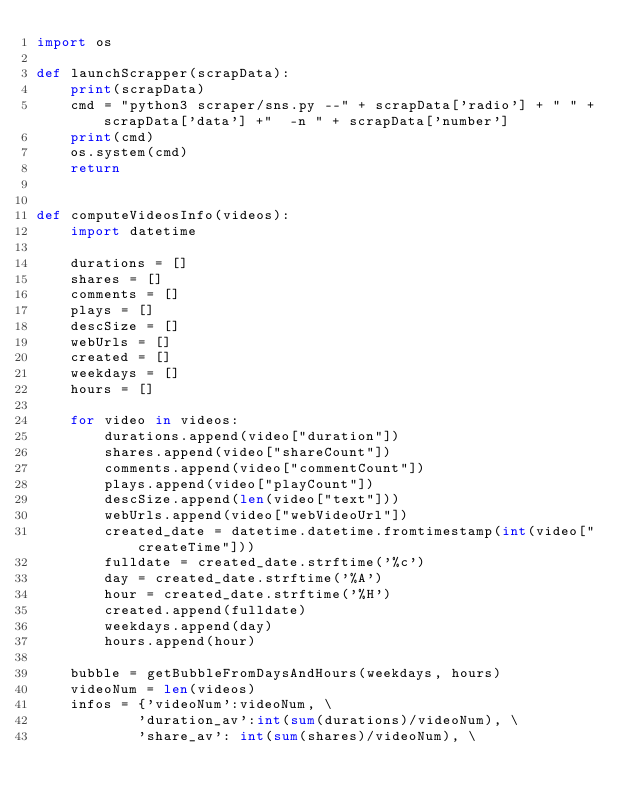Convert code to text. <code><loc_0><loc_0><loc_500><loc_500><_Python_>import os

def launchScrapper(scrapData):
    print(scrapData)
    cmd = "python3 scraper/sns.py --" + scrapData['radio'] + " " + scrapData['data'] +"  -n " + scrapData['number']
    print(cmd)
    os.system(cmd)
    return 


def computeVideosInfo(videos):
    import datetime

    durations = []
    shares = []
    comments = []
    plays = []
    descSize = []
    webUrls = []
    created = []
    weekdays = []
    hours = []

    for video in videos: 
        durations.append(video["duration"])
        shares.append(video["shareCount"])
        comments.append(video["commentCount"])
        plays.append(video["playCount"])
        descSize.append(len(video["text"]))
        webUrls.append(video["webVideoUrl"])
        created_date = datetime.datetime.fromtimestamp(int(video["createTime"]))
        fulldate = created_date.strftime('%c')
        day = created_date.strftime('%A')
        hour = created_date.strftime('%H')
        created.append(fulldate)
        weekdays.append(day)
        hours.append(hour)

    bubble = getBubbleFromDaysAndHours(weekdays, hours)
    videoNum = len(videos)
    infos = {'videoNum':videoNum, \
            'duration_av':int(sum(durations)/videoNum), \
            'share_av': int(sum(shares)/videoNum), \</code> 